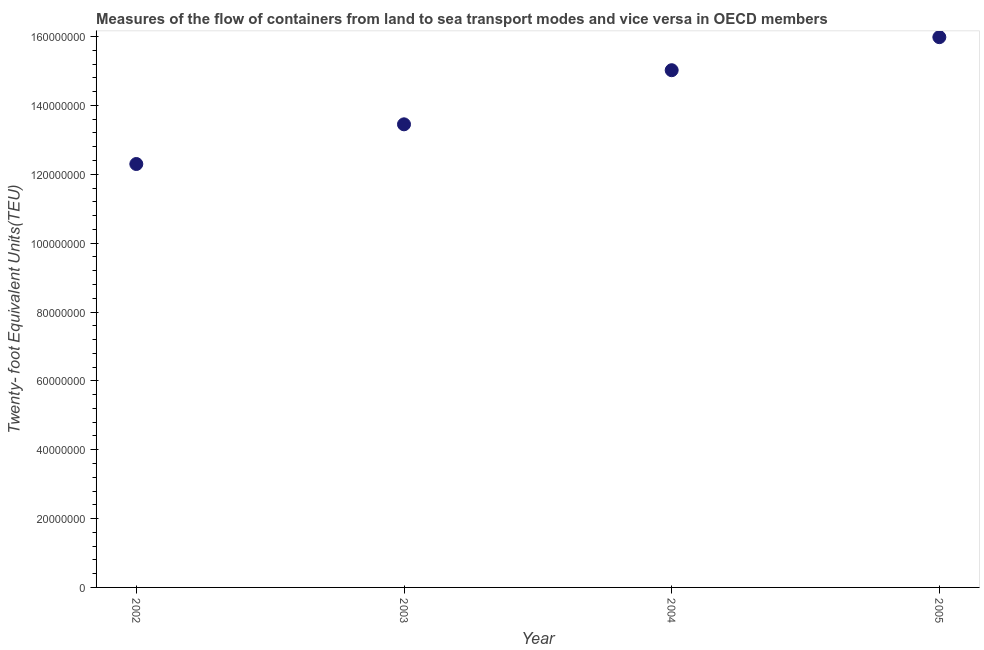What is the container port traffic in 2003?
Provide a short and direct response. 1.35e+08. Across all years, what is the maximum container port traffic?
Your answer should be compact. 1.60e+08. Across all years, what is the minimum container port traffic?
Provide a short and direct response. 1.23e+08. In which year was the container port traffic maximum?
Your answer should be very brief. 2005. What is the sum of the container port traffic?
Provide a succinct answer. 5.68e+08. What is the difference between the container port traffic in 2002 and 2003?
Ensure brevity in your answer.  -1.15e+07. What is the average container port traffic per year?
Your response must be concise. 1.42e+08. What is the median container port traffic?
Keep it short and to the point. 1.42e+08. Do a majority of the years between 2003 and 2002 (inclusive) have container port traffic greater than 92000000 TEU?
Your answer should be compact. No. What is the ratio of the container port traffic in 2002 to that in 2005?
Provide a short and direct response. 0.77. What is the difference between the highest and the second highest container port traffic?
Your answer should be very brief. 9.60e+06. Is the sum of the container port traffic in 2002 and 2004 greater than the maximum container port traffic across all years?
Your answer should be compact. Yes. What is the difference between the highest and the lowest container port traffic?
Your answer should be very brief. 3.68e+07. How many years are there in the graph?
Make the answer very short. 4. Are the values on the major ticks of Y-axis written in scientific E-notation?
Ensure brevity in your answer.  No. What is the title of the graph?
Offer a terse response. Measures of the flow of containers from land to sea transport modes and vice versa in OECD members. What is the label or title of the Y-axis?
Ensure brevity in your answer.  Twenty- foot Equivalent Units(TEU). What is the Twenty- foot Equivalent Units(TEU) in 2002?
Offer a terse response. 1.23e+08. What is the Twenty- foot Equivalent Units(TEU) in 2003?
Offer a very short reply. 1.35e+08. What is the Twenty- foot Equivalent Units(TEU) in 2004?
Ensure brevity in your answer.  1.50e+08. What is the Twenty- foot Equivalent Units(TEU) in 2005?
Give a very brief answer. 1.60e+08. What is the difference between the Twenty- foot Equivalent Units(TEU) in 2002 and 2003?
Give a very brief answer. -1.15e+07. What is the difference between the Twenty- foot Equivalent Units(TEU) in 2002 and 2004?
Ensure brevity in your answer.  -2.72e+07. What is the difference between the Twenty- foot Equivalent Units(TEU) in 2002 and 2005?
Your answer should be very brief. -3.68e+07. What is the difference between the Twenty- foot Equivalent Units(TEU) in 2003 and 2004?
Keep it short and to the point. -1.57e+07. What is the difference between the Twenty- foot Equivalent Units(TEU) in 2003 and 2005?
Offer a very short reply. -2.53e+07. What is the difference between the Twenty- foot Equivalent Units(TEU) in 2004 and 2005?
Provide a succinct answer. -9.60e+06. What is the ratio of the Twenty- foot Equivalent Units(TEU) in 2002 to that in 2003?
Offer a terse response. 0.91. What is the ratio of the Twenty- foot Equivalent Units(TEU) in 2002 to that in 2004?
Provide a short and direct response. 0.82. What is the ratio of the Twenty- foot Equivalent Units(TEU) in 2002 to that in 2005?
Offer a terse response. 0.77. What is the ratio of the Twenty- foot Equivalent Units(TEU) in 2003 to that in 2004?
Provide a succinct answer. 0.9. What is the ratio of the Twenty- foot Equivalent Units(TEU) in 2003 to that in 2005?
Give a very brief answer. 0.84. What is the ratio of the Twenty- foot Equivalent Units(TEU) in 2004 to that in 2005?
Offer a terse response. 0.94. 